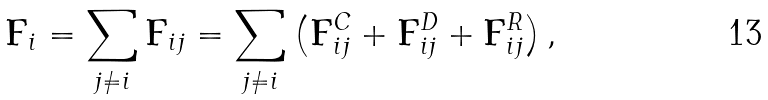<formula> <loc_0><loc_0><loc_500><loc_500>\mathbf F _ { i } = \sum _ { j \not = i } \mathbf F _ { i j } = \sum _ { j \not = i } \left ( \mathbf F _ { i j } ^ { C } + \mathbf F _ { i j } ^ { D } + \mathbf F _ { i j } ^ { R } \right ) ,</formula> 